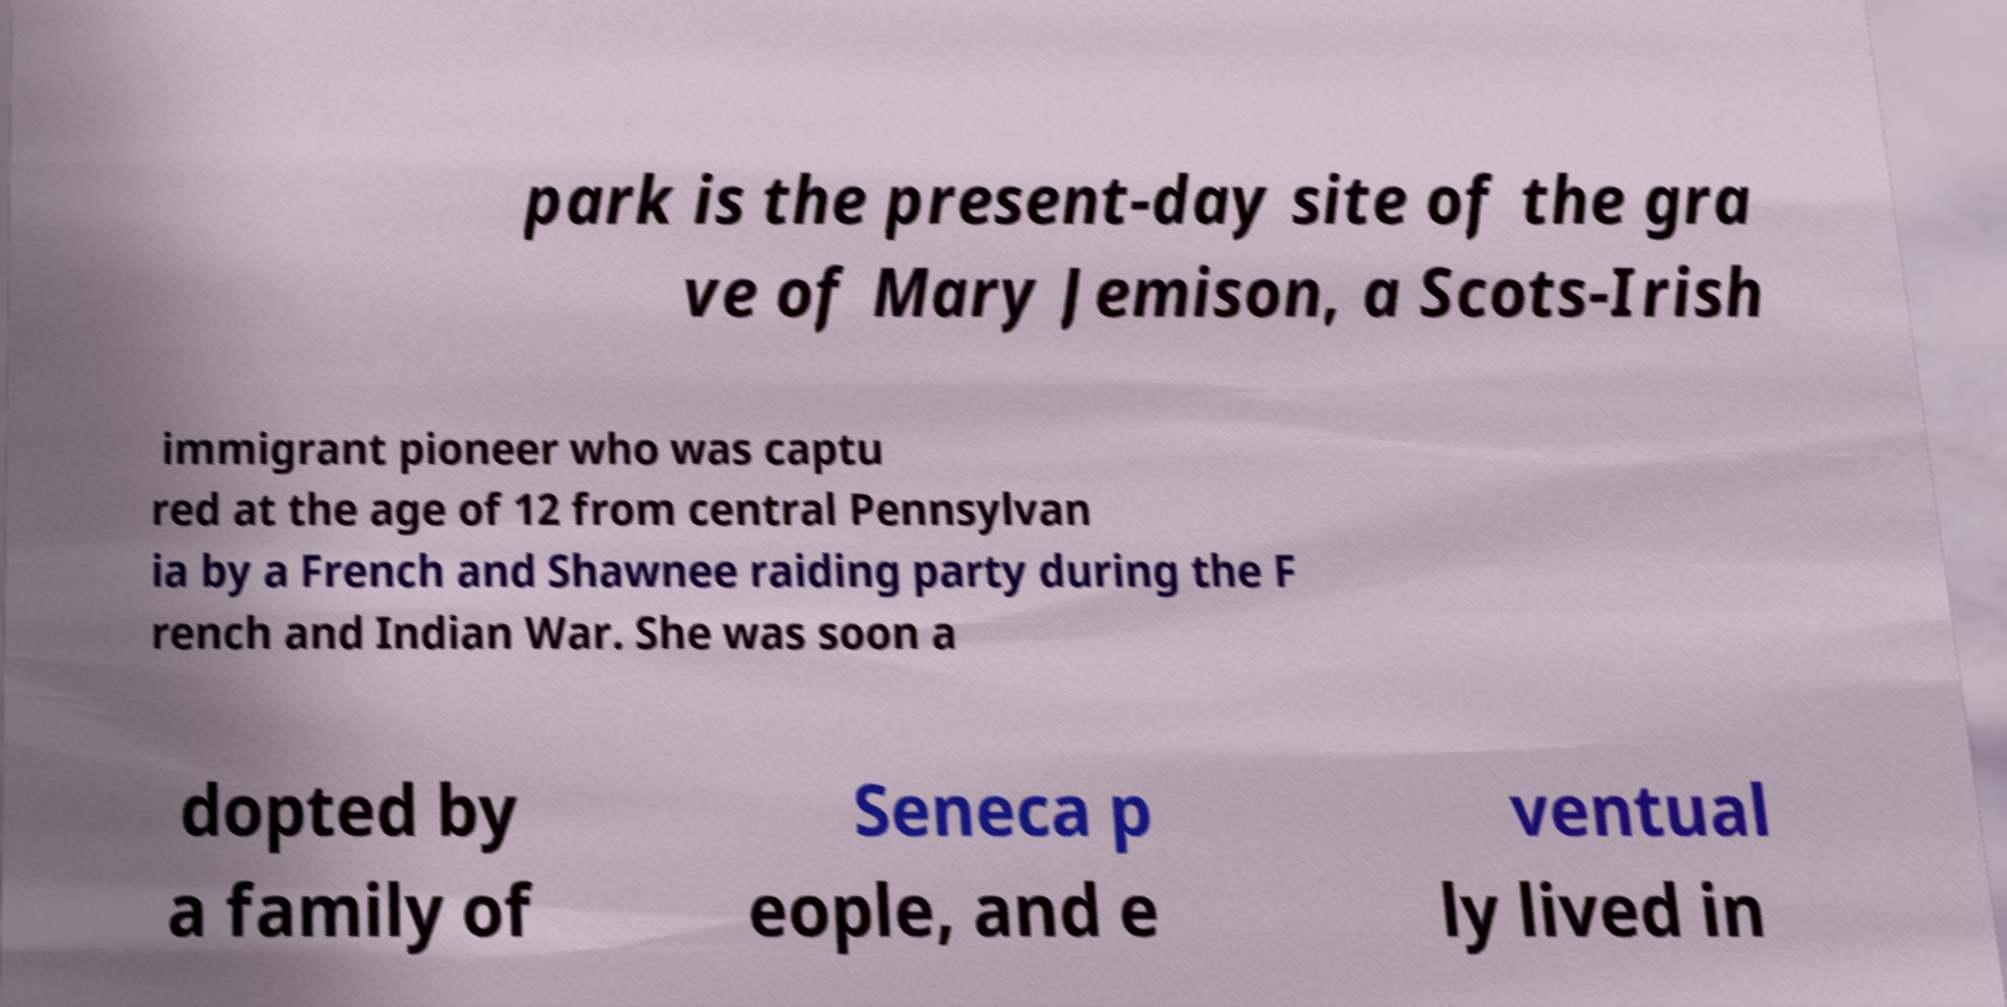For documentation purposes, I need the text within this image transcribed. Could you provide that? park is the present-day site of the gra ve of Mary Jemison, a Scots-Irish immigrant pioneer who was captu red at the age of 12 from central Pennsylvan ia by a French and Shawnee raiding party during the F rench and Indian War. She was soon a dopted by a family of Seneca p eople, and e ventual ly lived in 